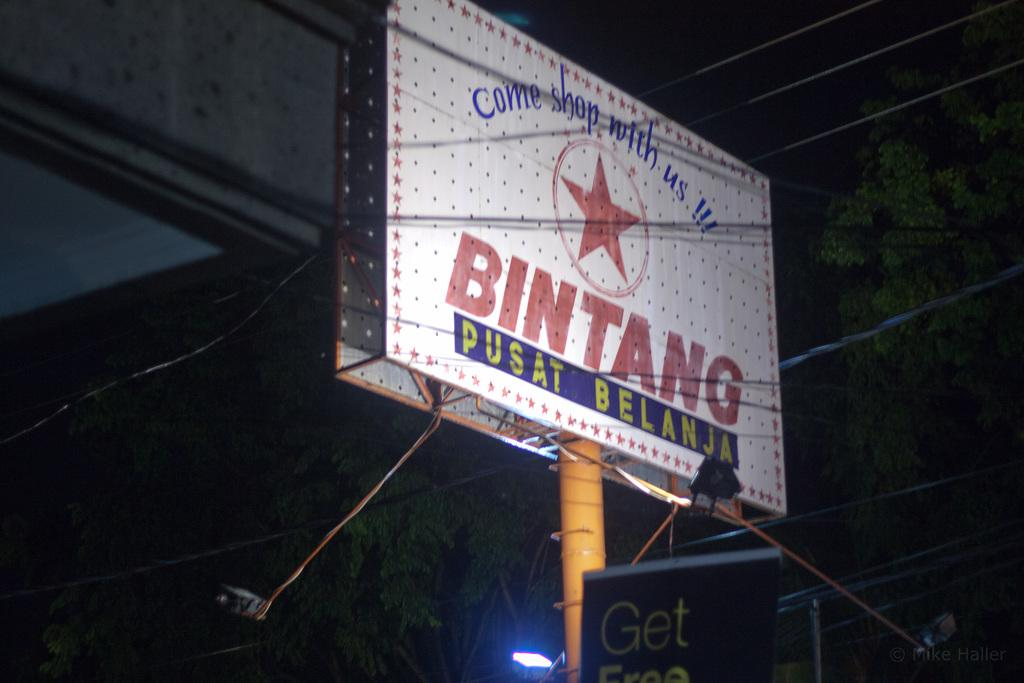<image>
Render a clear and concise summary of the photo. The sign advertises a shop and wants you to come shop with us. 